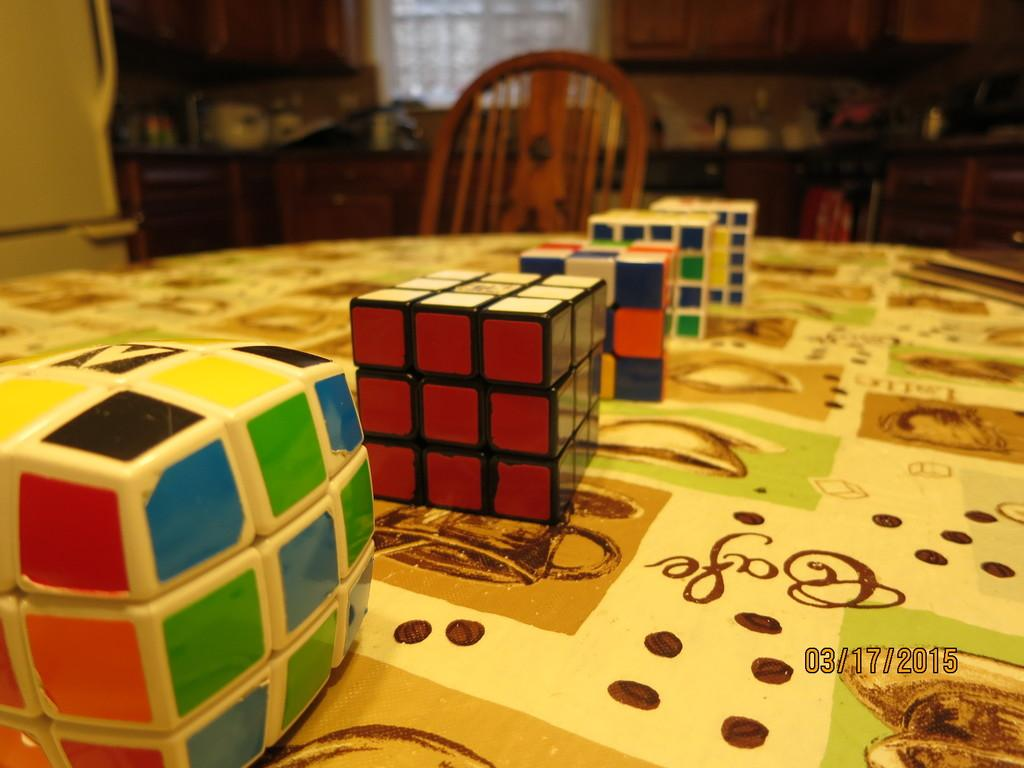What objects are on the table in the image? There are rubix cubes on the table. What type of furniture can be seen in the background of the image? There is a cabinet and a chair placed on the floor in the background of the image. What other objects are visible in the background of the image? There are cupboards, a refrigerator, and a window in the background of the image. Can you describe the objects placed on the cabinet? The facts provided do not specify the objects placed on the cabinet. What type of cook is preparing a meal in the image? There is no cook or meal preparation visible in the image. What type of cast is visible in the image? There is no cast present in the image. 